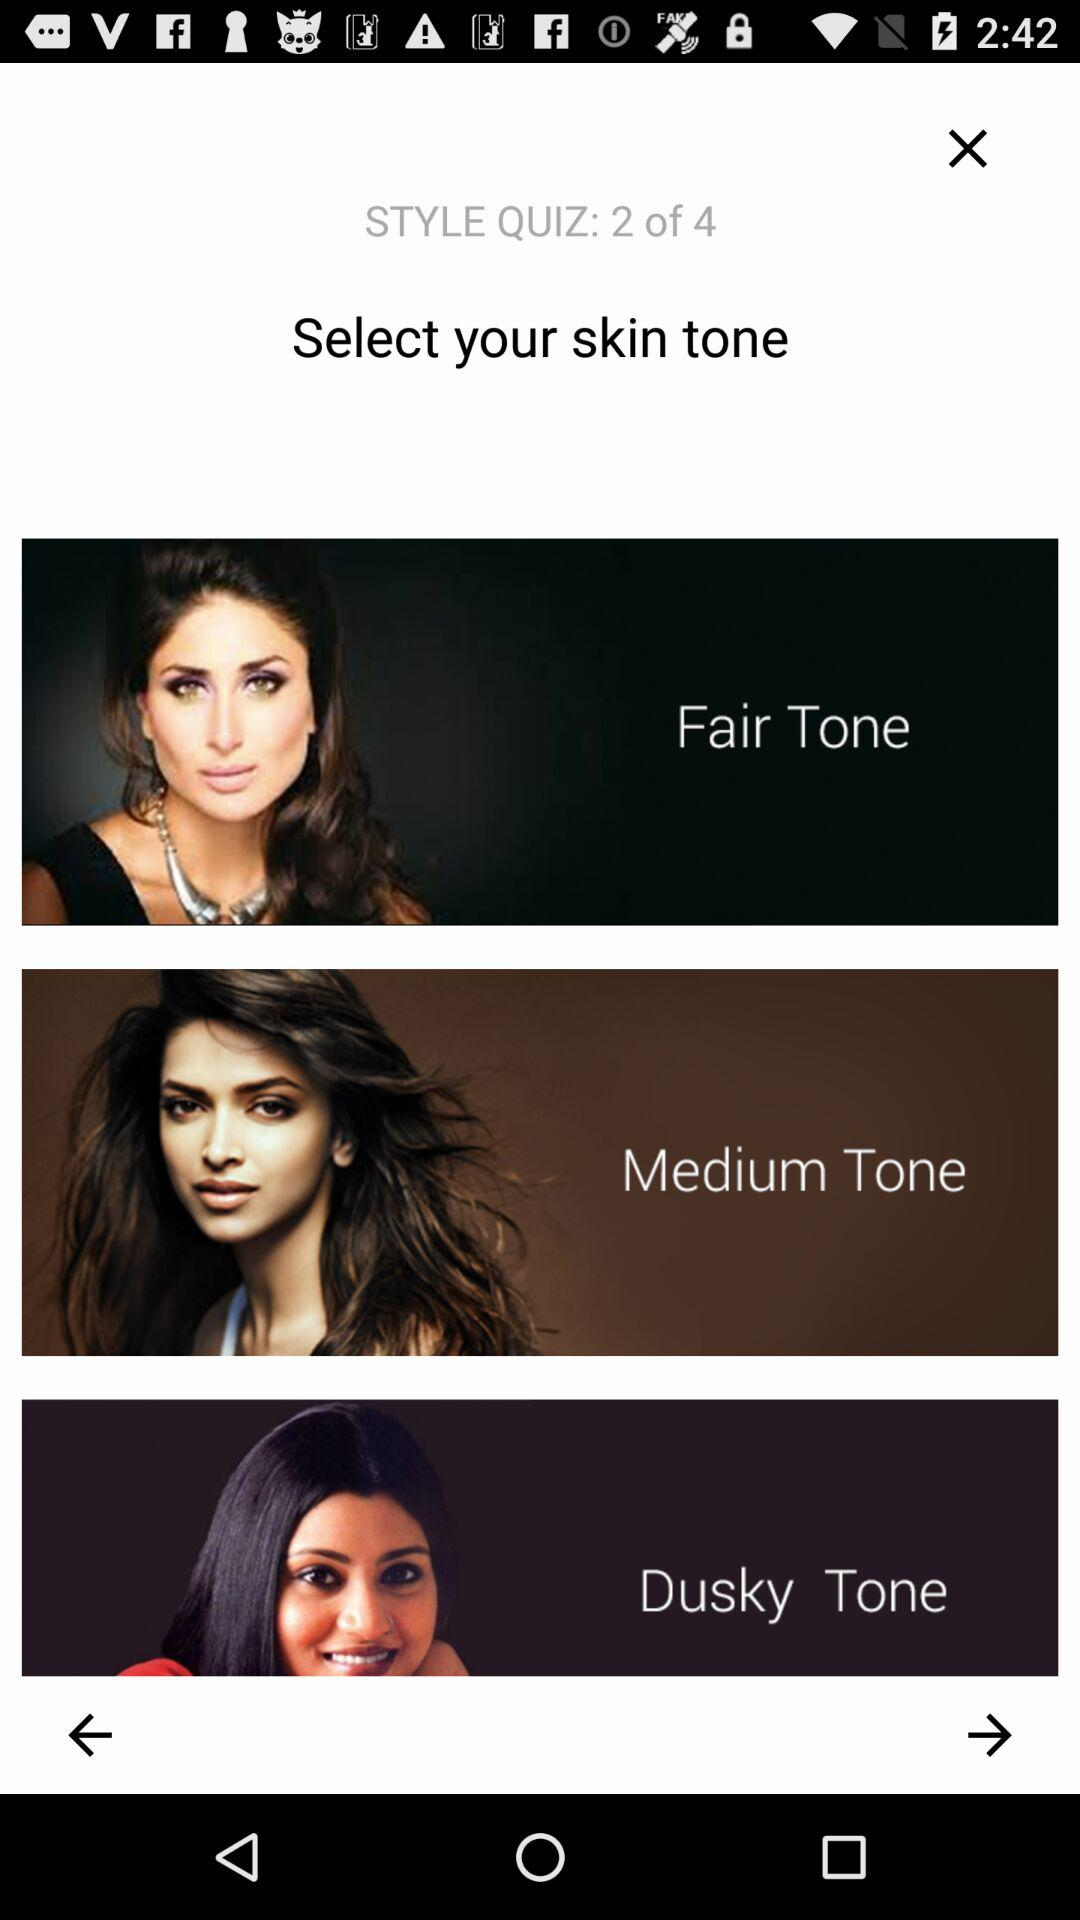How many skin tone options are there?
Answer the question using a single word or phrase. 3 